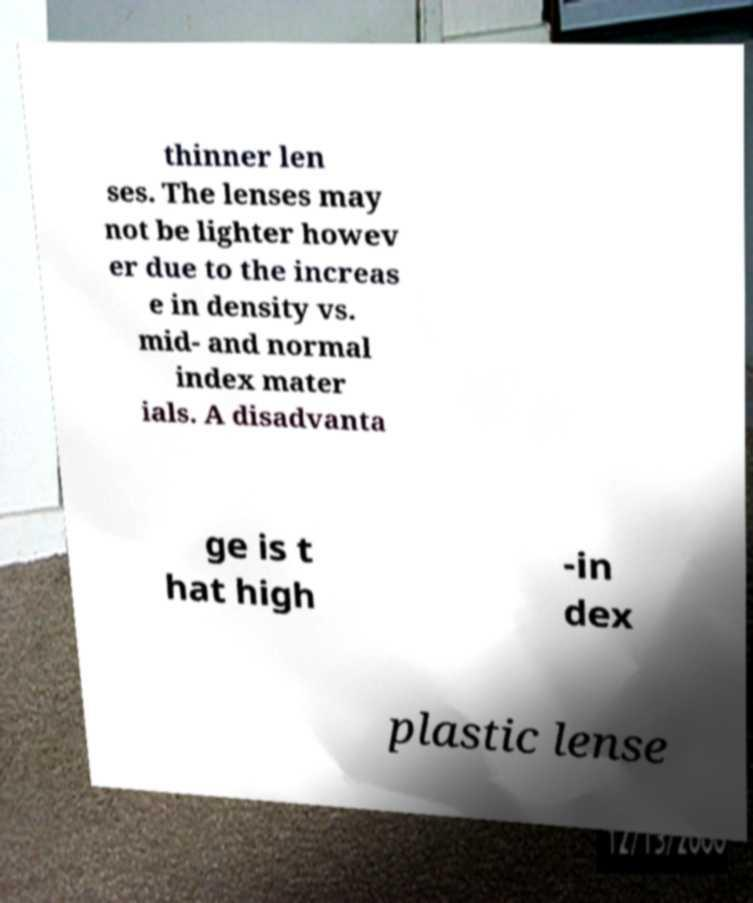Can you read and provide the text displayed in the image?This photo seems to have some interesting text. Can you extract and type it out for me? thinner len ses. The lenses may not be lighter howev er due to the increas e in density vs. mid- and normal index mater ials. A disadvanta ge is t hat high -in dex plastic lense 